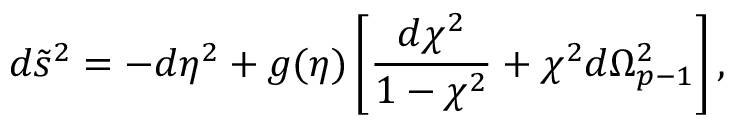<formula> <loc_0><loc_0><loc_500><loc_500>d \tilde { s } ^ { 2 } = - d \eta ^ { 2 } + g ( \eta ) \left [ { \frac { d \chi ^ { 2 } } { 1 - \chi ^ { 2 } } } + \chi ^ { 2 } d \Omega _ { p - 1 } ^ { 2 } \right ] ,</formula> 